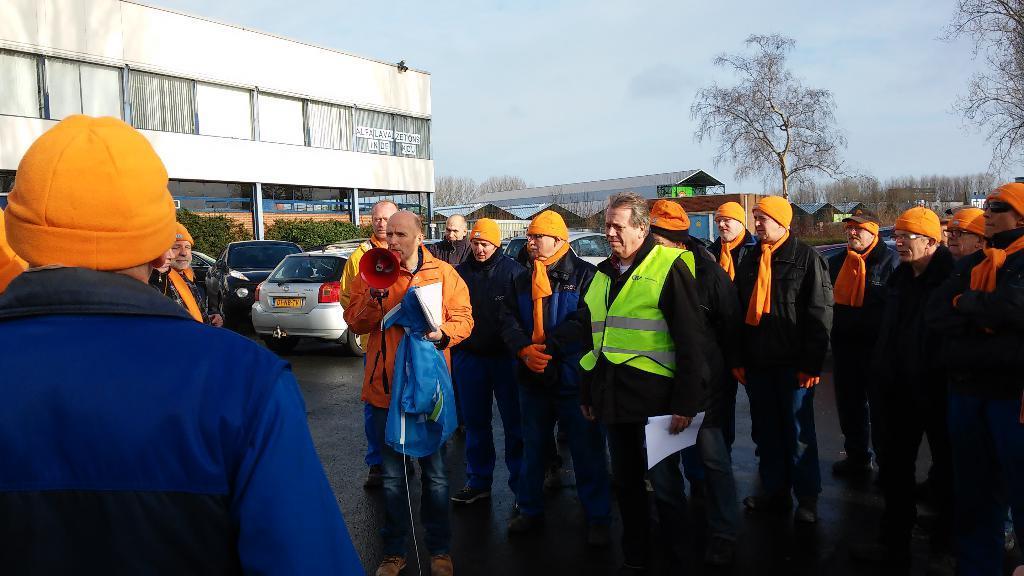Could you give a brief overview of what you see in this image? In this picture there is a group of men wearing orange color turban on the head, standing and listening to the person who is giving a speech. Behind there is a white color small house with glasses, shed house and some dry trees. 